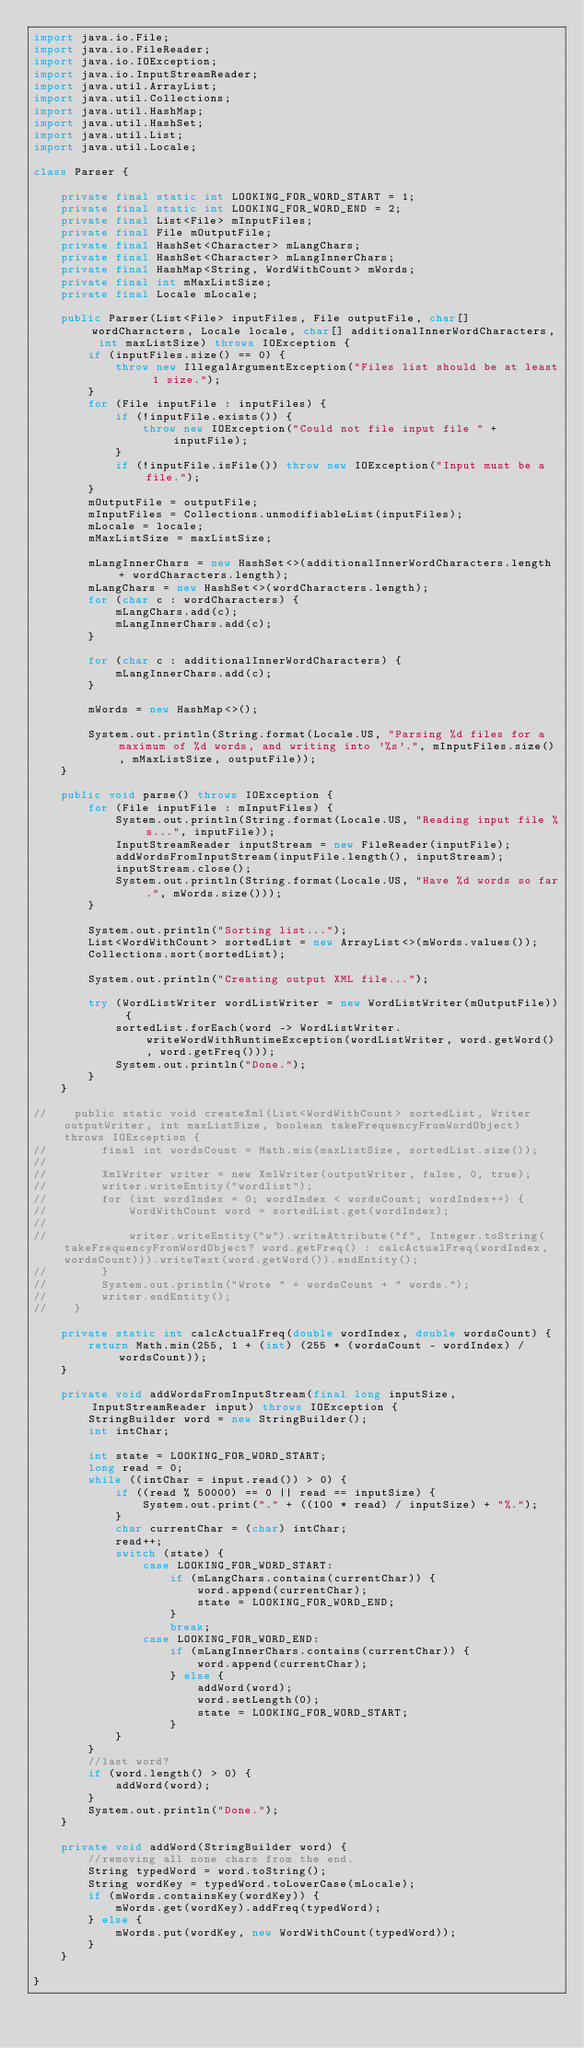Convert code to text. <code><loc_0><loc_0><loc_500><loc_500><_Java_>import java.io.File;
import java.io.FileReader;
import java.io.IOException;
import java.io.InputStreamReader;
import java.util.ArrayList;
import java.util.Collections;
import java.util.HashMap;
import java.util.HashSet;
import java.util.List;
import java.util.Locale;

class Parser {

    private final static int LOOKING_FOR_WORD_START = 1;
    private final static int LOOKING_FOR_WORD_END = 2;
    private final List<File> mInputFiles;
    private final File mOutputFile;
    private final HashSet<Character> mLangChars;
    private final HashSet<Character> mLangInnerChars;
    private final HashMap<String, WordWithCount> mWords;
    private final int mMaxListSize;
    private final Locale mLocale;

    public Parser(List<File> inputFiles, File outputFile, char[] wordCharacters, Locale locale, char[] additionalInnerWordCharacters, int maxListSize) throws IOException {
        if (inputFiles.size() == 0) {
            throw new IllegalArgumentException("Files list should be at least 1 size.");
        }
        for (File inputFile : inputFiles) {
            if (!inputFile.exists()) {
                throw new IOException("Could not file input file " + inputFile);
            }
            if (!inputFile.isFile()) throw new IOException("Input must be a file.");
        }
        mOutputFile = outputFile;
        mInputFiles = Collections.unmodifiableList(inputFiles);
        mLocale = locale;
        mMaxListSize = maxListSize;

        mLangInnerChars = new HashSet<>(additionalInnerWordCharacters.length + wordCharacters.length);
        mLangChars = new HashSet<>(wordCharacters.length);
        for (char c : wordCharacters) {
            mLangChars.add(c);
            mLangInnerChars.add(c);
        }

        for (char c : additionalInnerWordCharacters) {
            mLangInnerChars.add(c);
        }

        mWords = new HashMap<>();

        System.out.println(String.format(Locale.US, "Parsing %d files for a maximum of %d words, and writing into '%s'.", mInputFiles.size(), mMaxListSize, outputFile));
    }

    public void parse() throws IOException {
        for (File inputFile : mInputFiles) {
            System.out.println(String.format(Locale.US, "Reading input file %s...", inputFile));
            InputStreamReader inputStream = new FileReader(inputFile);
            addWordsFromInputStream(inputFile.length(), inputStream);
            inputStream.close();
            System.out.println(String.format(Locale.US, "Have %d words so far.", mWords.size()));
        }

        System.out.println("Sorting list...");
        List<WordWithCount> sortedList = new ArrayList<>(mWords.values());
        Collections.sort(sortedList);

        System.out.println("Creating output XML file...");

        try (WordListWriter wordListWriter = new WordListWriter(mOutputFile)) {
            sortedList.forEach(word -> WordListWriter.writeWordWithRuntimeException(wordListWriter, word.getWord(), word.getFreq()));
            System.out.println("Done.");
        }
    }

//    public static void createXml(List<WordWithCount> sortedList, Writer outputWriter, int maxListSize, boolean takeFrequencyFromWordObject) throws IOException {
//        final int wordsCount = Math.min(maxListSize, sortedList.size());
//
//        XmlWriter writer = new XmlWriter(outputWriter, false, 0, true);
//        writer.writeEntity("wordlist");
//        for (int wordIndex = 0; wordIndex < wordsCount; wordIndex++) {
//            WordWithCount word = sortedList.get(wordIndex);
//
//            writer.writeEntity("w").writeAttribute("f", Integer.toString(takeFrequencyFromWordObject? word.getFreq() : calcActualFreq(wordIndex, wordsCount))).writeText(word.getWord()).endEntity();
//        }
//        System.out.println("Wrote " + wordsCount + " words.");
//        writer.endEntity();
//    }

    private static int calcActualFreq(double wordIndex, double wordsCount) {
        return Math.min(255, 1 + (int) (255 * (wordsCount - wordIndex) / wordsCount));
    }

    private void addWordsFromInputStream(final long inputSize, InputStreamReader input) throws IOException {
        StringBuilder word = new StringBuilder();
        int intChar;

        int state = LOOKING_FOR_WORD_START;
        long read = 0;
        while ((intChar = input.read()) > 0) {
            if ((read % 50000) == 0 || read == inputSize) {
                System.out.print("." + ((100 * read) / inputSize) + "%.");
            }
            char currentChar = (char) intChar;
            read++;
            switch (state) {
                case LOOKING_FOR_WORD_START:
                    if (mLangChars.contains(currentChar)) {
                        word.append(currentChar);
                        state = LOOKING_FOR_WORD_END;
                    }
                    break;
                case LOOKING_FOR_WORD_END:
                    if (mLangInnerChars.contains(currentChar)) {
                        word.append(currentChar);
                    } else {
                        addWord(word);
                        word.setLength(0);
                        state = LOOKING_FOR_WORD_START;
                    }
            }
        }
        //last word?
        if (word.length() > 0) {
            addWord(word);
        }
        System.out.println("Done.");
    }

    private void addWord(StringBuilder word) {
        //removing all none chars from the end.
        String typedWord = word.toString();
        String wordKey = typedWord.toLowerCase(mLocale);
        if (mWords.containsKey(wordKey)) {
            mWords.get(wordKey).addFreq(typedWord);
        } else {
            mWords.put(wordKey, new WordWithCount(typedWord));
        }
    }

}
</code> 